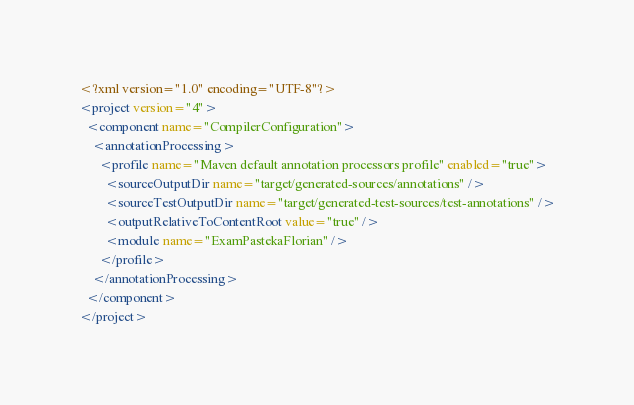<code> <loc_0><loc_0><loc_500><loc_500><_XML_><?xml version="1.0" encoding="UTF-8"?>
<project version="4">
  <component name="CompilerConfiguration">
    <annotationProcessing>
      <profile name="Maven default annotation processors profile" enabled="true">
        <sourceOutputDir name="target/generated-sources/annotations" />
        <sourceTestOutputDir name="target/generated-test-sources/test-annotations" />
        <outputRelativeToContentRoot value="true" />
        <module name="ExamPastekaFlorian" />
      </profile>
    </annotationProcessing>
  </component>
</project></code> 